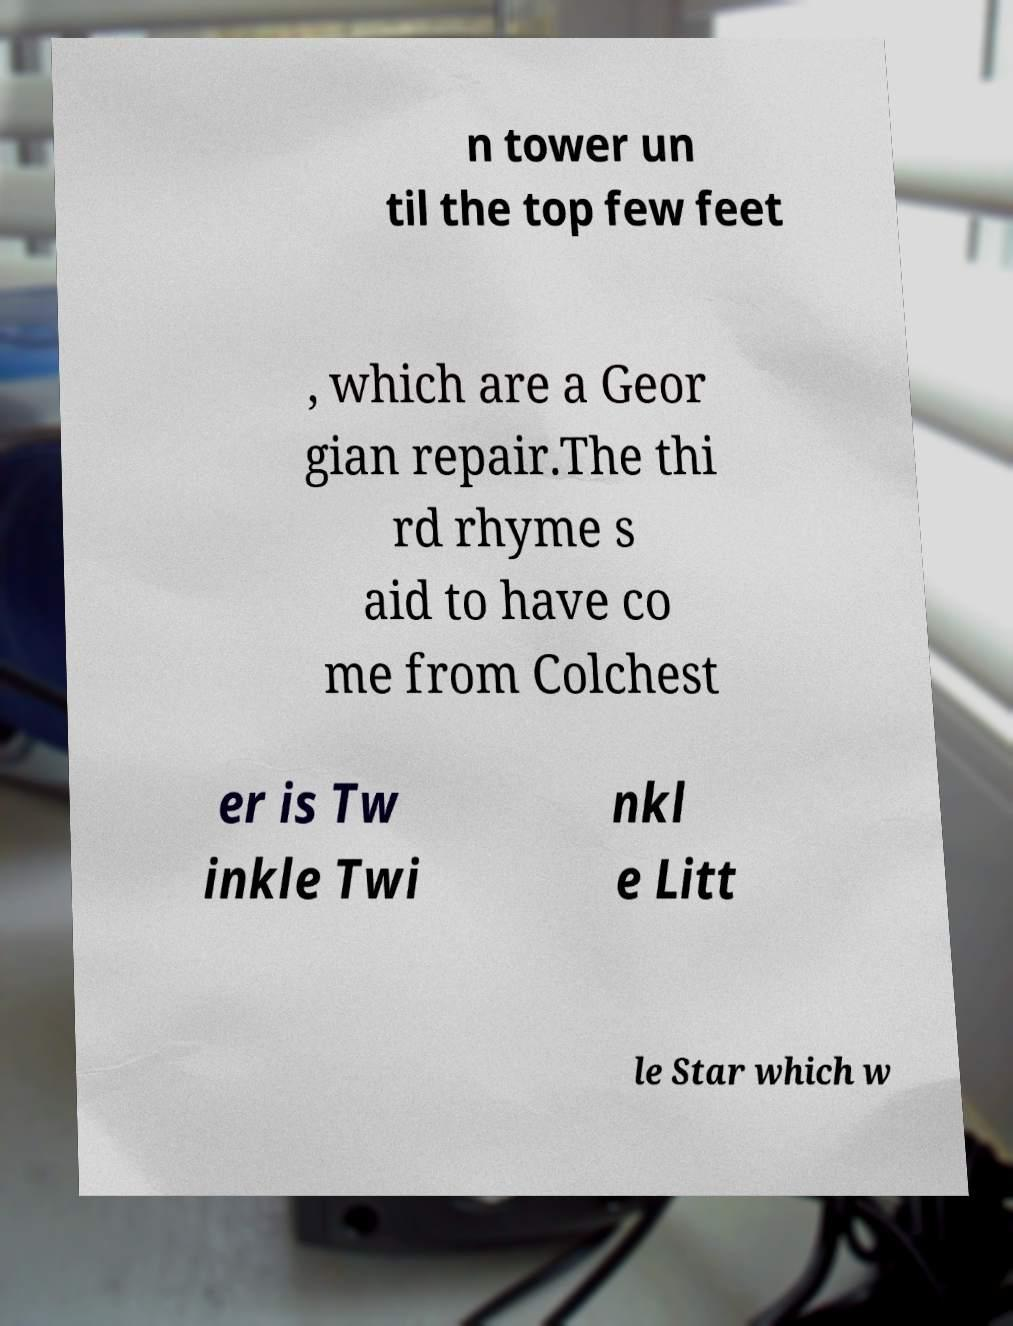Can you read and provide the text displayed in the image?This photo seems to have some interesting text. Can you extract and type it out for me? n tower un til the top few feet , which are a Geor gian repair.The thi rd rhyme s aid to have co me from Colchest er is Tw inkle Twi nkl e Litt le Star which w 